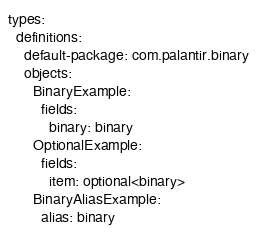<code> <loc_0><loc_0><loc_500><loc_500><_YAML_>types:
  definitions:
    default-package: com.palantir.binary
    objects:
      BinaryExample:
        fields:
          binary: binary
      OptionalExample:
        fields:
          item: optional<binary>
      BinaryAliasExample:
        alias: binary
</code> 